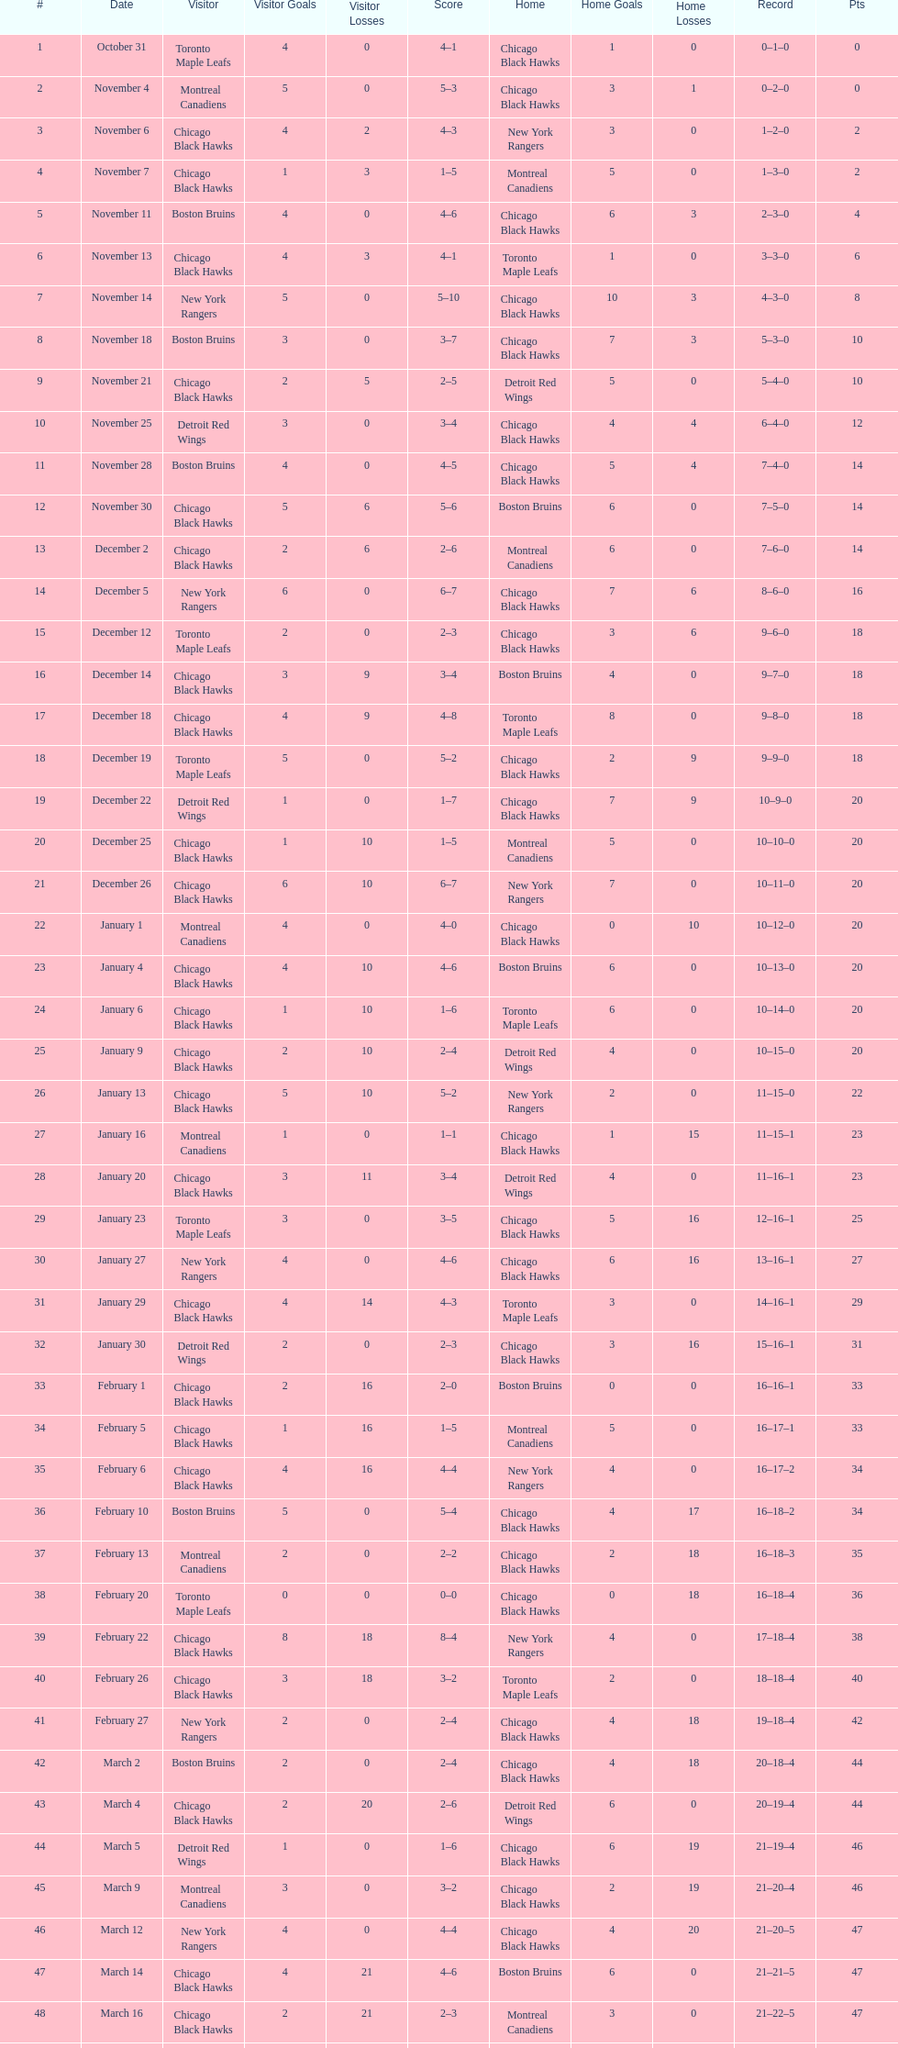On december 14 was the home team the chicago black hawks or the boston bruins? Boston Bruins. 